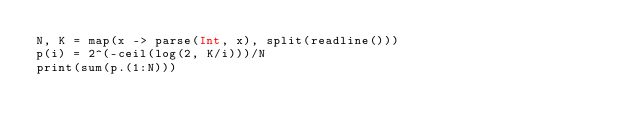Convert code to text. <code><loc_0><loc_0><loc_500><loc_500><_Julia_>N, K = map(x -> parse(Int, x), split(readline()))
p(i) = 2^(-ceil(log(2, K/i)))/N
print(sum(p.(1:N)))</code> 